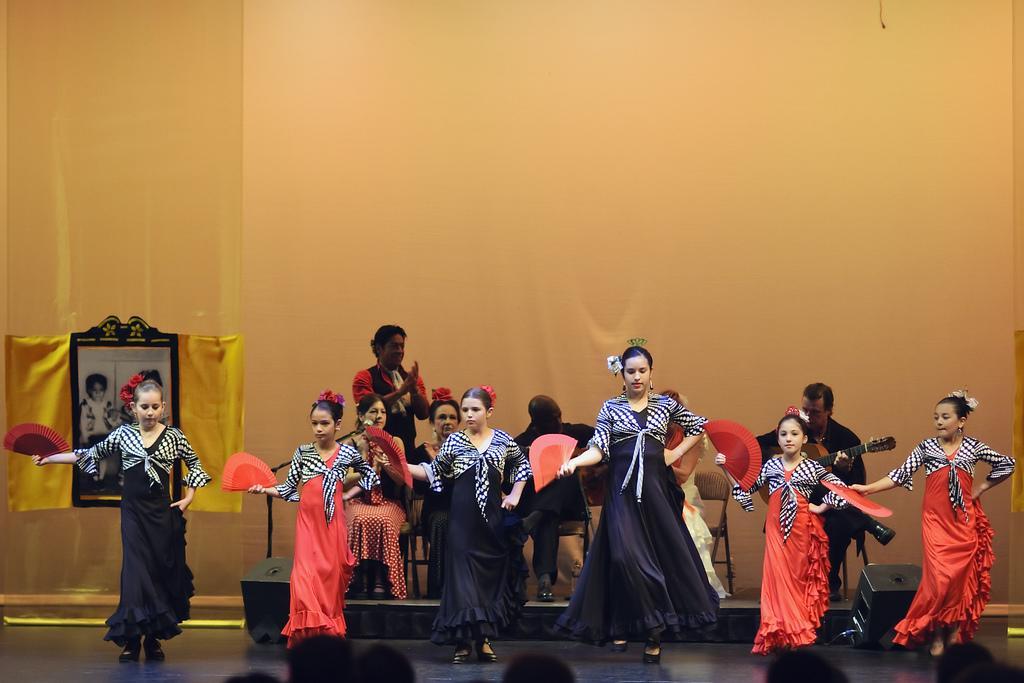Describe this image in one or two sentences. In the picture we can see some girls are dancing with different costumes and behind them, we can see some men are sitting on the chairs and playing musical instruments and one man is standing and clapping and behind them we can see a wall with a photo frame beside them in person image in it. 